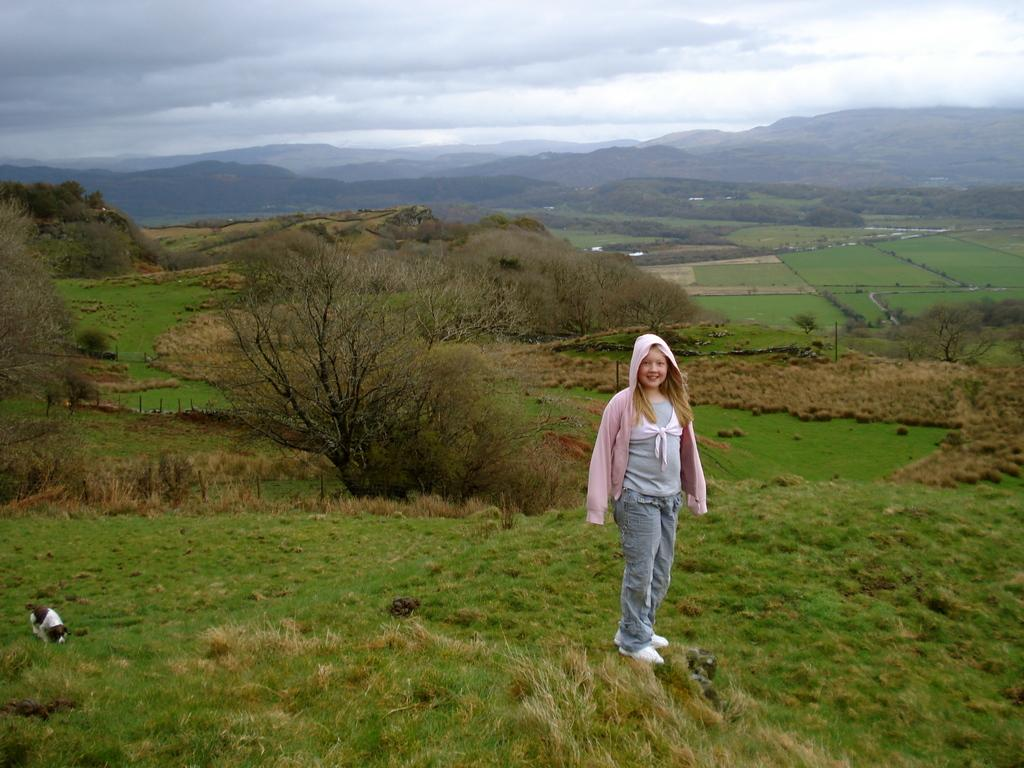What type of vegetation is present in the image? There is grass in the image. What other natural elements can be seen in the image? There are trees and hills visible in the image. What living creature is present in the image? There is a dog in the image. Are there any human figures in the image? Yes, there is a girl standing in the image. What is visible at the top of the image? The sky is visible at the top of the image, and there are clouds in the sky. How many sheep are visible in the image? There are no sheep present in the image. What role does the actor play in the image? There is no actor present in the image. 